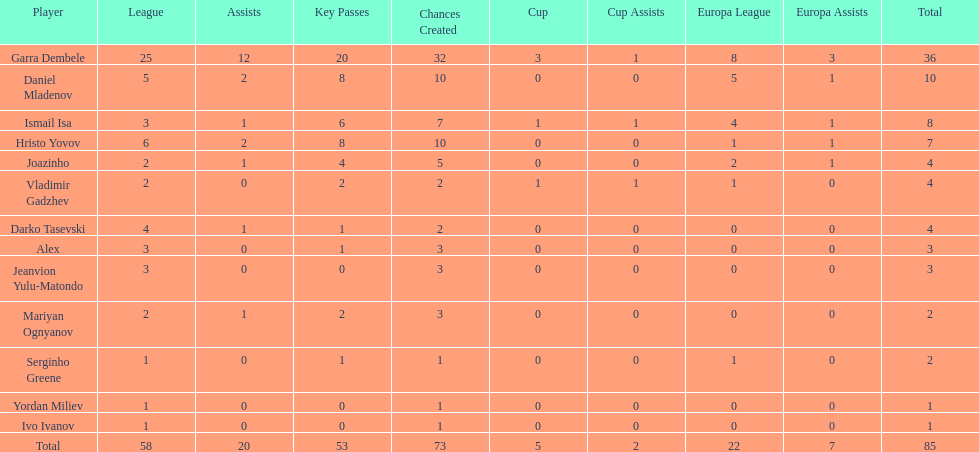What is the sum of the cup total and the europa league total? 27. 